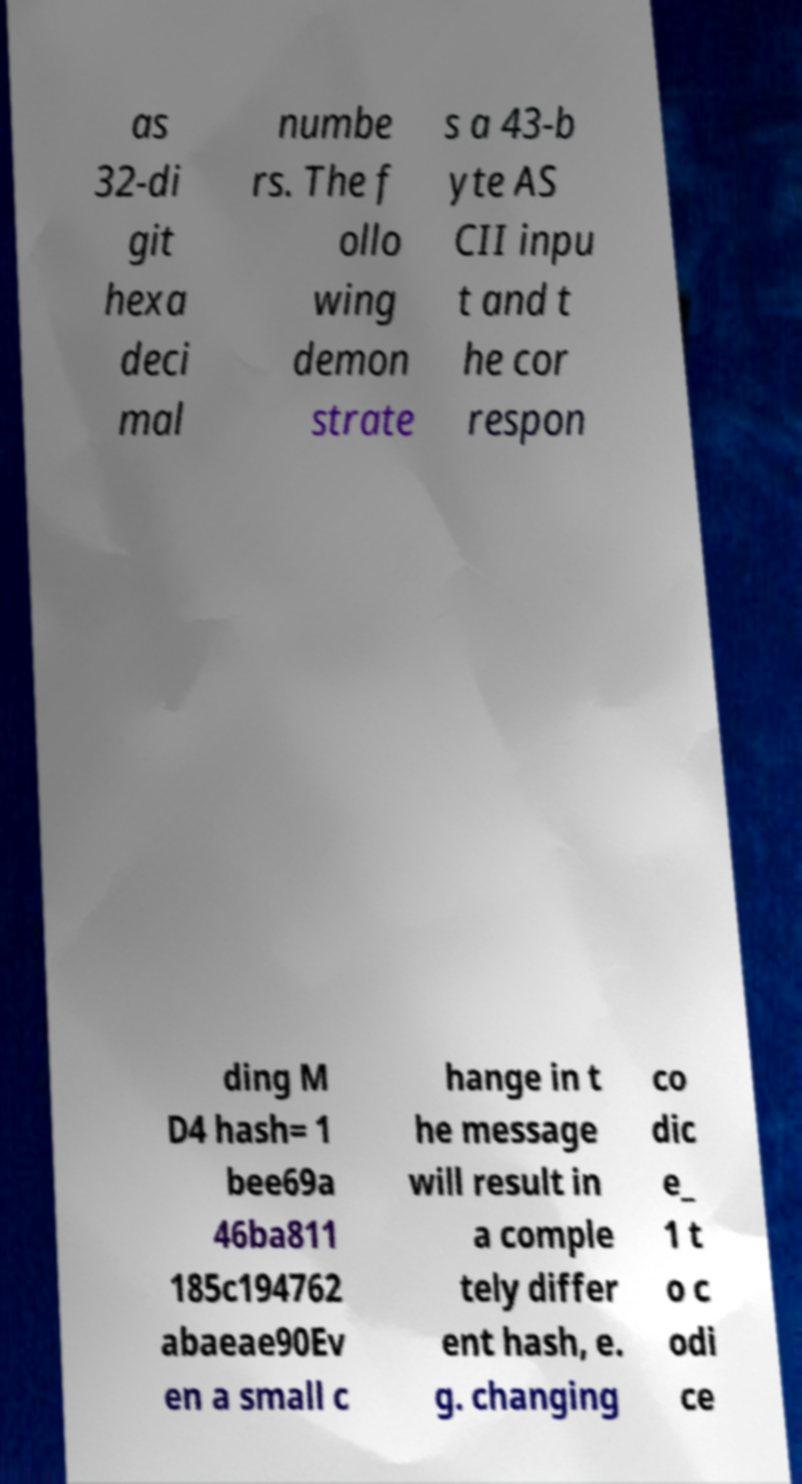There's text embedded in this image that I need extracted. Can you transcribe it verbatim? as 32-di git hexa deci mal numbe rs. The f ollo wing demon strate s a 43-b yte AS CII inpu t and t he cor respon ding M D4 hash= 1 bee69a 46ba811 185c194762 abaeae90Ev en a small c hange in t he message will result in a comple tely differ ent hash, e. g. changing co dic e_ 1 t o c odi ce 